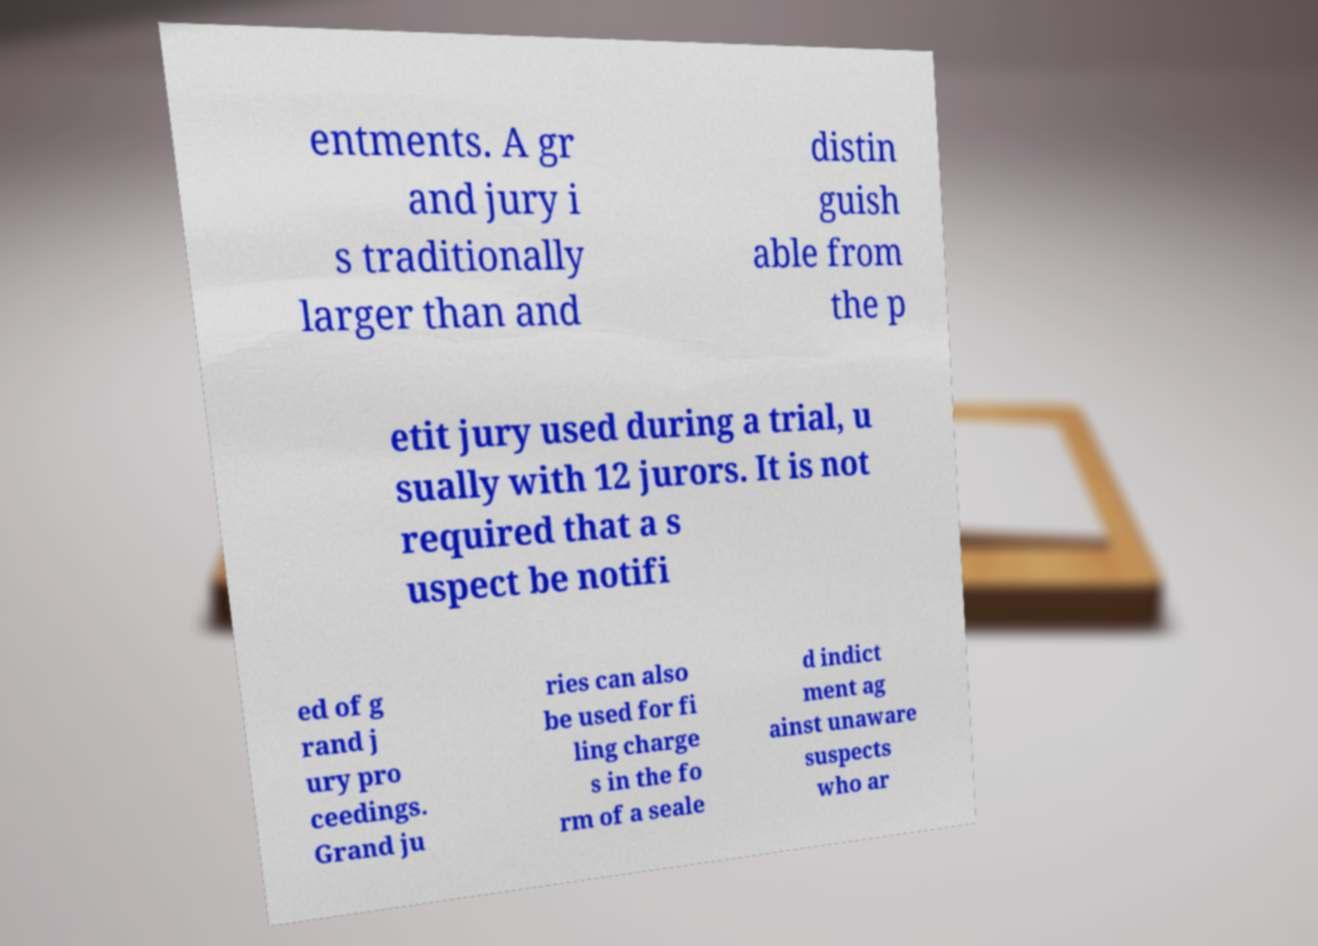Please identify and transcribe the text found in this image. entments. A gr and jury i s traditionally larger than and distin guish able from the p etit jury used during a trial, u sually with 12 jurors. It is not required that a s uspect be notifi ed of g rand j ury pro ceedings. Grand ju ries can also be used for fi ling charge s in the fo rm of a seale d indict ment ag ainst unaware suspects who ar 